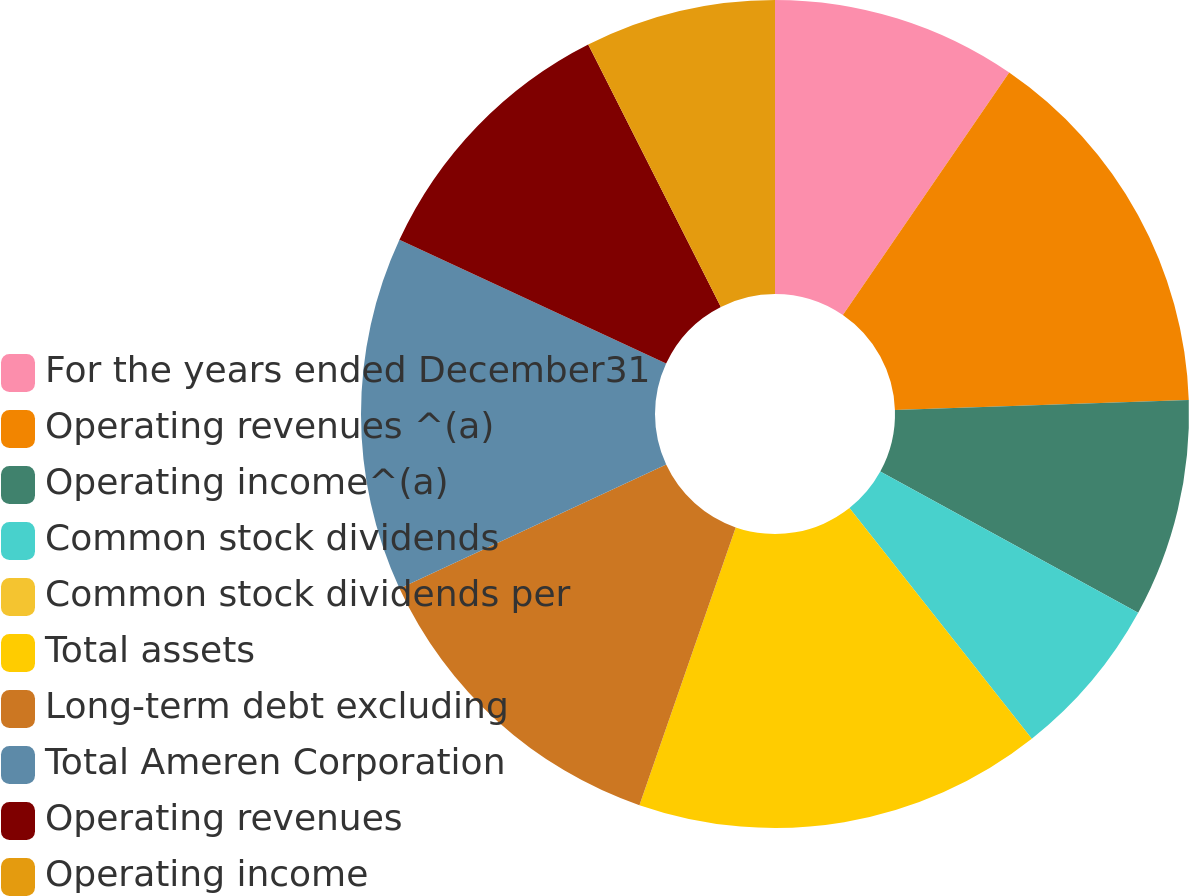Convert chart to OTSL. <chart><loc_0><loc_0><loc_500><loc_500><pie_chart><fcel>For the years ended December31<fcel>Operating revenues ^(a)<fcel>Operating income^(a)<fcel>Common stock dividends<fcel>Common stock dividends per<fcel>Total assets<fcel>Long-term debt excluding<fcel>Total Ameren Corporation<fcel>Operating revenues<fcel>Operating income<nl><fcel>9.57%<fcel>14.89%<fcel>8.51%<fcel>6.38%<fcel>0.0%<fcel>15.96%<fcel>12.77%<fcel>13.83%<fcel>10.64%<fcel>7.45%<nl></chart> 